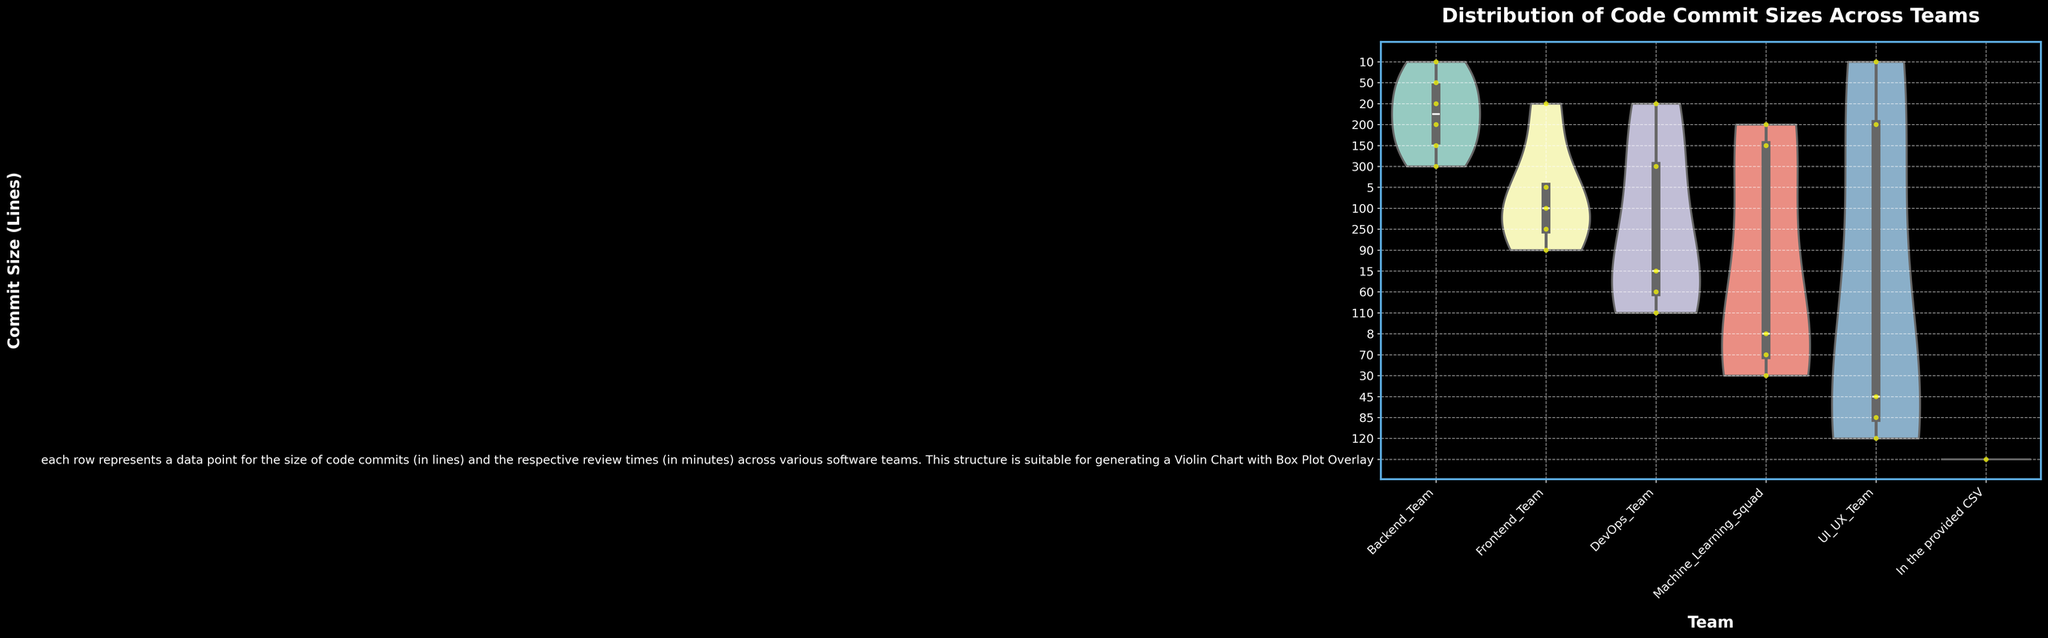What's the title of the figure? The title is displayed at the top of the figure. It helps to understand the main topic being visualized.
Answer: Distribution of Code Commit Sizes Across Teams Which team has the widest distribution of commit sizes? The width of the violin plot indicates the distribution range, and the team with the widest spread has the largest range. By examining the width, it can be seen that the Backend_Team has the widest distribution.
Answer: Backend_Team What is the median commit size for the Frontend_Team? The median is indicated by the line inside the box plot. Observing the Frontend_Team's box plot, we identify the middle line, representing the median commit size.
Answer: 90 How do the review times compare between small commit sizes (less than 50 lines) and large commit sizes (more than 200 lines)? Generally, smaller commit sizes tend to have smaller review times, and larger commit sizes have longer review times. By checking the corresponding data points on the swarm plot overlaid on the violin plots, this trend can be observed.
Answer: Smaller commits have shorter review times; larger commits have longer review times Which team shows the highest maximum commit size? The maximum commit size is indicated at the peak of the violin plot. By comparing the topmost points of each team's violin plots, we see that both Backend_Team and DevOps_Team reach the maximum around 300 lines.
Answer: Backend_Team and DevOps_Team Are there any teams with low variability in commit sizes? Variability can be assessed by the width and compactness of the violin plots. Teams with compact and thin violin plots exhibit lower variability. The Machine_Learning_Squad has one of the more compact distributions, indicating lower variability.
Answer: Machine_Learning_Squad What is the interquartile range (IQR) for the UI_UX_Team? The IQR is determined by the distance between the first and third quartile in the box plot. By measuring the vertical distance between the top and bottom edges of the box for the UI_UX_Team, the IQR is observed to be around 120 - 45 = 75 lines.
Answer: 75 lines Which team has the smallest median commit size? The median size is marked by the midline of the box plot. Comparing all the midlines, the UI_UX_Team has the smallest median commit size at around 10 lines.
Answer: UI_UX_Team Is there a team where the commit size appears skewed? Skewness is detected by an asymmetrical shape of the violin plot. If one tail of the plot is longer than the other, it indicates skewness. The Frontend_Team shows a right (positive) skew with a longer tail towards larger commit sizes.
Answer: Frontend_Team Which team has the most commit size outliers? Outliers are identified by individual points outside the range of the violin plot. By counting the number of distinct points lying outside the main body of the violin plots, the Backend_Team shows the most outliers.
Answer: Backend_Team 